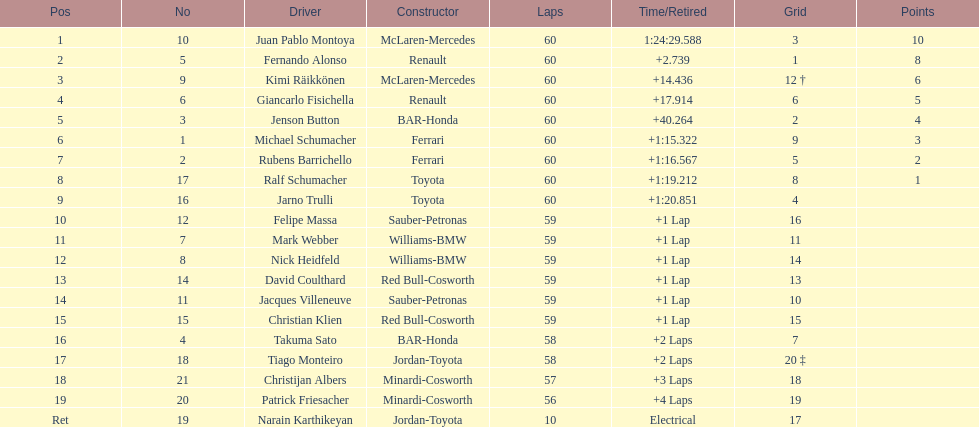Could you help me parse every detail presented in this table? {'header': ['Pos', 'No', 'Driver', 'Constructor', 'Laps', 'Time/Retired', 'Grid', 'Points'], 'rows': [['1', '10', 'Juan Pablo Montoya', 'McLaren-Mercedes', '60', '1:24:29.588', '3', '10'], ['2', '5', 'Fernando Alonso', 'Renault', '60', '+2.739', '1', '8'], ['3', '9', 'Kimi Räikkönen', 'McLaren-Mercedes', '60', '+14.436', '12 †', '6'], ['4', '6', 'Giancarlo Fisichella', 'Renault', '60', '+17.914', '6', '5'], ['5', '3', 'Jenson Button', 'BAR-Honda', '60', '+40.264', '2', '4'], ['6', '1', 'Michael Schumacher', 'Ferrari', '60', '+1:15.322', '9', '3'], ['7', '2', 'Rubens Barrichello', 'Ferrari', '60', '+1:16.567', '5', '2'], ['8', '17', 'Ralf Schumacher', 'Toyota', '60', '+1:19.212', '8', '1'], ['9', '16', 'Jarno Trulli', 'Toyota', '60', '+1:20.851', '4', ''], ['10', '12', 'Felipe Massa', 'Sauber-Petronas', '59', '+1 Lap', '16', ''], ['11', '7', 'Mark Webber', 'Williams-BMW', '59', '+1 Lap', '11', ''], ['12', '8', 'Nick Heidfeld', 'Williams-BMW', '59', '+1 Lap', '14', ''], ['13', '14', 'David Coulthard', 'Red Bull-Cosworth', '59', '+1 Lap', '13', ''], ['14', '11', 'Jacques Villeneuve', 'Sauber-Petronas', '59', '+1 Lap', '10', ''], ['15', '15', 'Christian Klien', 'Red Bull-Cosworth', '59', '+1 Lap', '15', ''], ['16', '4', 'Takuma Sato', 'BAR-Honda', '58', '+2 Laps', '7', ''], ['17', '18', 'Tiago Monteiro', 'Jordan-Toyota', '58', '+2 Laps', '20 ‡', ''], ['18', '21', 'Christijan Albers', 'Minardi-Cosworth', '57', '+3 Laps', '18', ''], ['19', '20', 'Patrick Friesacher', 'Minardi-Cosworth', '56', '+4 Laps', '19', ''], ['Ret', '19', 'Narain Karthikeyan', 'Jordan-Toyota', '10', 'Electrical', '17', '']]} What is the number of toyota's on the list? 4. 